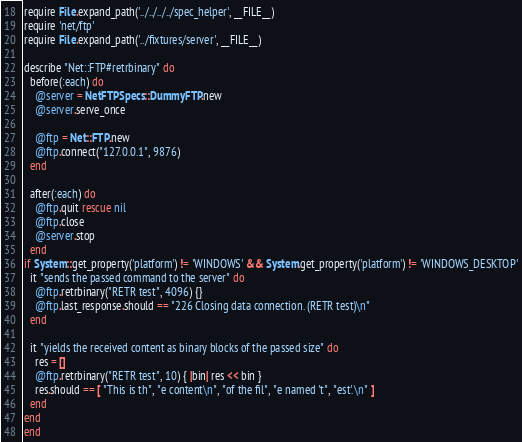<code> <loc_0><loc_0><loc_500><loc_500><_Ruby_>require File.expand_path('../../../../spec_helper', __FILE__)
require 'net/ftp'
require File.expand_path('../fixtures/server', __FILE__)

describe "Net::FTP#retrbinary" do
  before(:each) do
    @server = NetFTPSpecs::DummyFTP.new
    @server.serve_once

    @ftp = Net::FTP.new
    @ftp.connect("127.0.0.1", 9876)
  end

  after(:each) do
    @ftp.quit rescue nil
    @ftp.close
    @server.stop
  end
if System::get_property('platform') != 'WINDOWS' && System.get_property('platform') != 'WINDOWS_DESKTOP'
  it "sends the passed command to the server" do
    @ftp.retrbinary("RETR test", 4096) {}
    @ftp.last_response.should == "226 Closing data connection. (RETR test)\n"
  end

  it "yields the received content as binary blocks of the passed size" do
    res = []
    @ftp.retrbinary("RETR test", 10) { |bin| res << bin }
    res.should == [ "This is th", "e content\n", "of the fil", "e named 't", "est'.\n" ]
  end
end  
end
</code> 